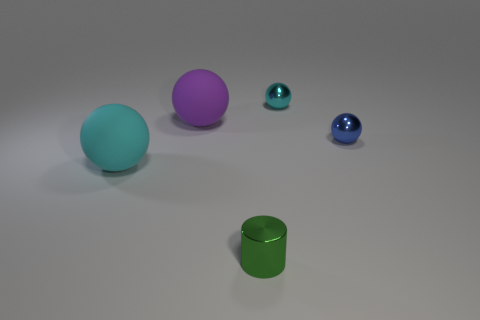Subtract 2 balls. How many balls are left? 2 Subtract all tiny blue spheres. How many spheres are left? 3 Add 4 small green things. How many objects exist? 9 Subtract all cylinders. How many objects are left? 4 Add 5 large purple rubber cubes. How many large purple rubber cubes exist? 5 Subtract 1 green cylinders. How many objects are left? 4 Subtract all small things. Subtract all tiny green things. How many objects are left? 1 Add 4 small blue balls. How many small blue balls are left? 5 